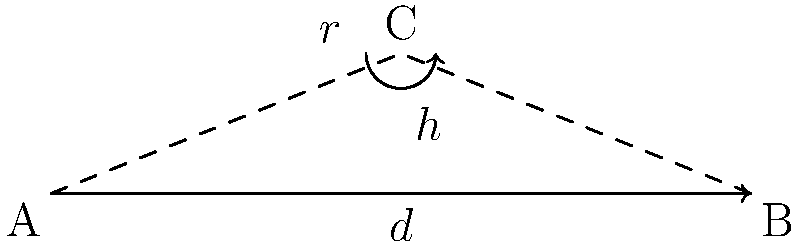In a line-of-sight microwave link between two points A and B, the distance between the points is 40 km, and the frequency of the microwave signal is 6 GHz. What is the radius of the first Fresnel zone at the midpoint of the link, rounded to the nearest meter? To calculate the radius of the first Fresnel zone at the midpoint of the link, we can use the following formula:

$$ r = \sqrt{\frac{\lambda d_1 d_2}{d}} $$

Where:
$r$ = radius of the first Fresnel zone
$\lambda$ = wavelength of the signal
$d_1$ = distance from one end to the point of calculation
$d_2$ = distance from the other end to the point of calculation
$d$ = total distance of the link

Steps:
1. Calculate the wavelength $\lambda$:
   $\lambda = \frac{c}{f} = \frac{3 \times 10^8 \text{ m/s}}{6 \times 10^9 \text{ Hz}} = 0.05 \text{ m}$

2. At the midpoint, $d_1 = d_2 = \frac{d}{2} = 20 \text{ km}$

3. Substitute into the formula:
   $$ r = \sqrt{\frac{0.05 \text{ m} \times 20000 \text{ m} \times 20000 \text{ m}}{40000 \text{ m}}} $$

4. Simplify and calculate:
   $$ r = \sqrt{500} \approx 22.36 \text{ m} $$

5. Round to the nearest meter:
   $r \approx 22 \text{ m}$
Answer: 22 m 